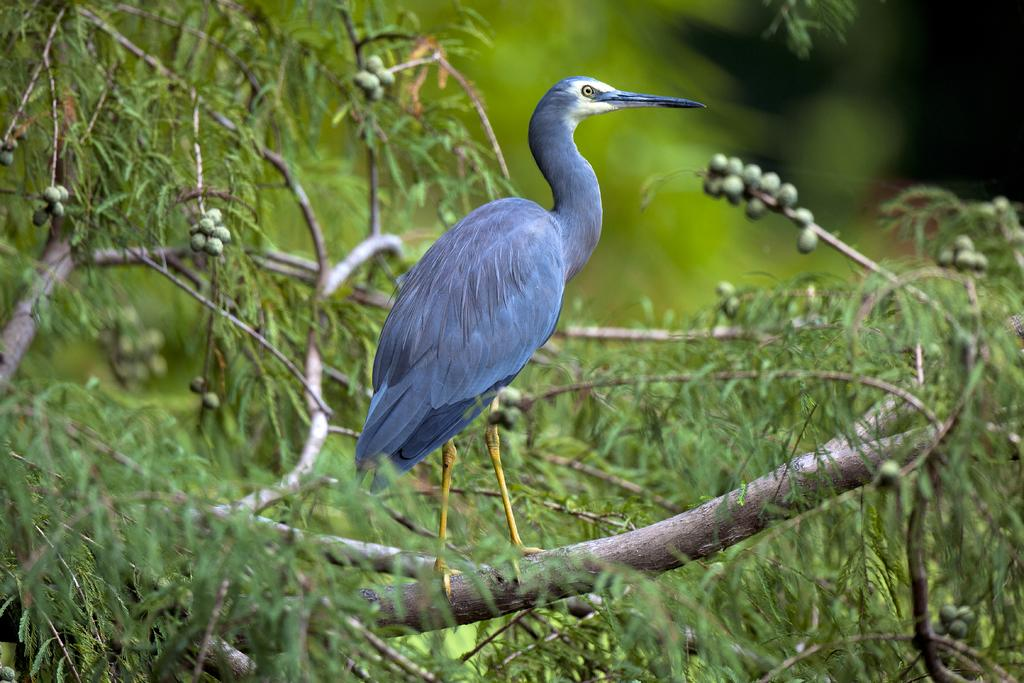What type of animal can be seen in the image? There is a bird in the image. Where is the bird located? The bird is on a tree. Can you describe the background of the image? The background of the image is blurred. What type of cabbage is the bird eating in the image? There is no cabbage present in the image; the bird is on a tree. Is the bird playing baseball in the image? There is no baseball or any indication of a baseball game in the image; the bird is on a tree. 